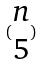Convert formula to latex. <formula><loc_0><loc_0><loc_500><loc_500>( \begin{matrix} n \\ 5 \end{matrix} )</formula> 